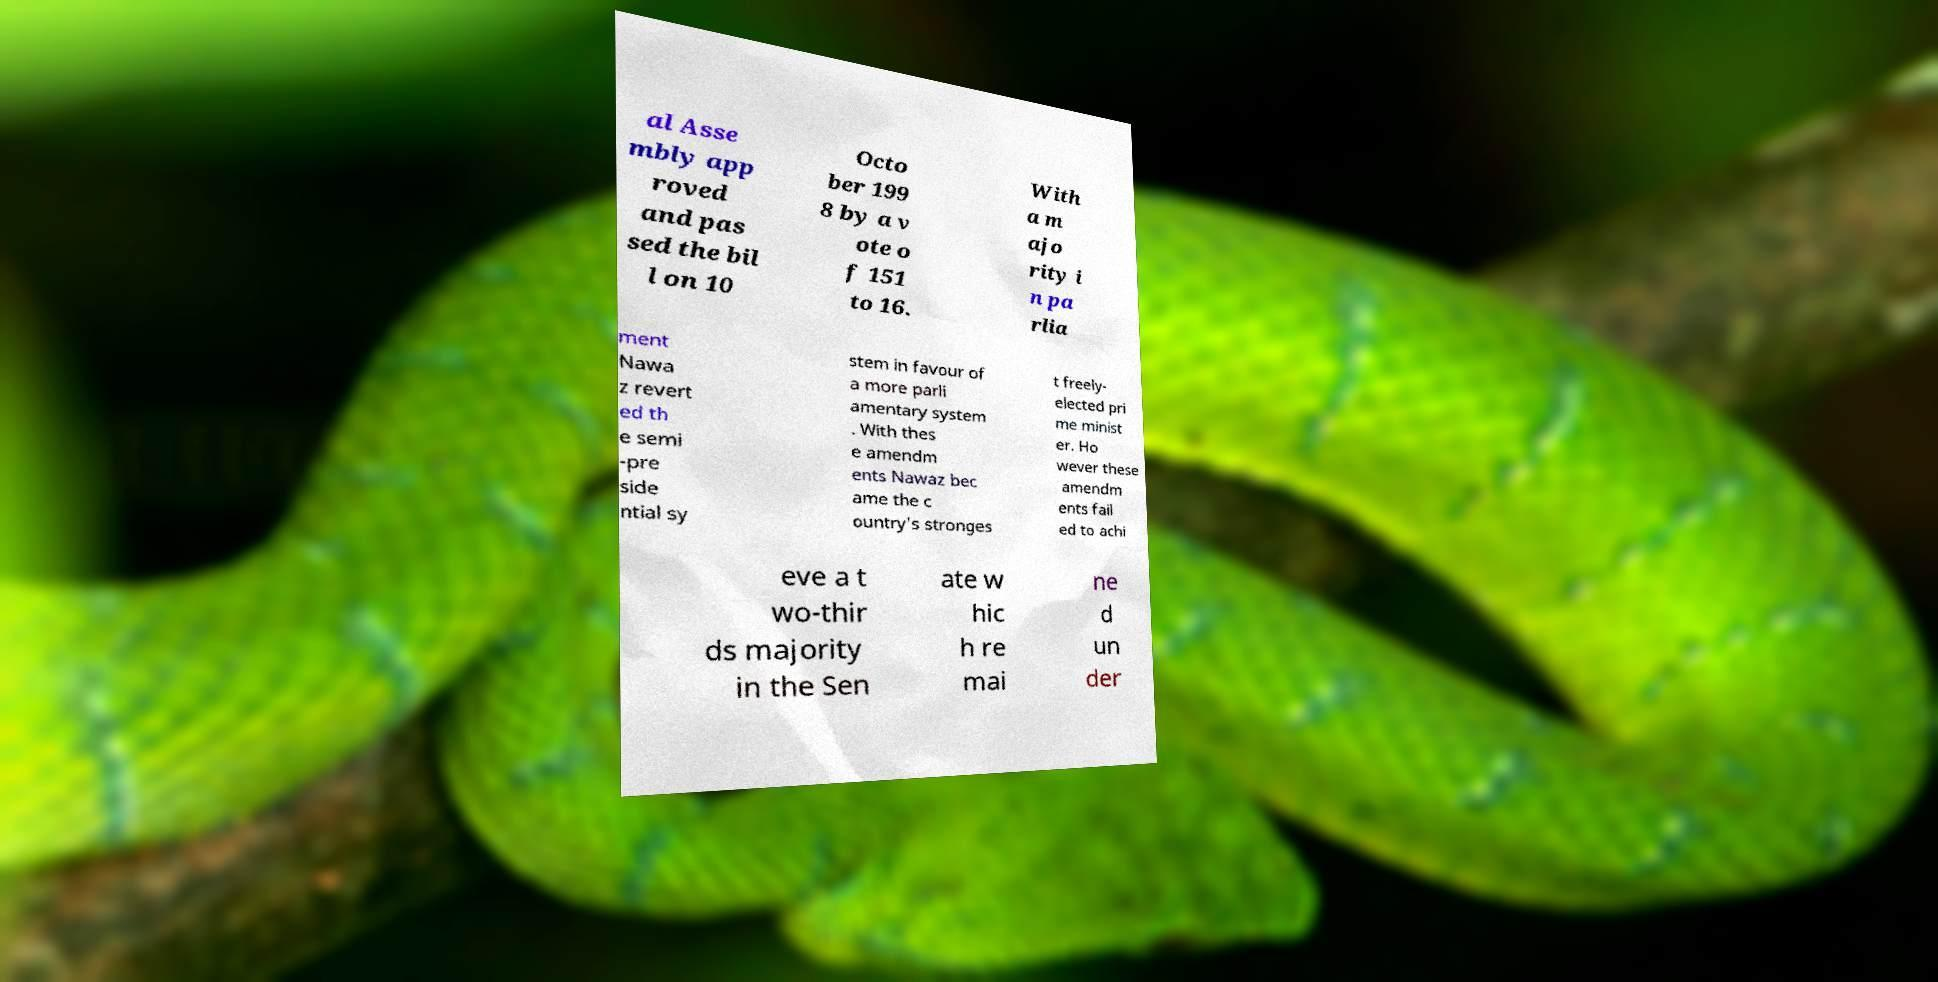Please identify and transcribe the text found in this image. al Asse mbly app roved and pas sed the bil l on 10 Octo ber 199 8 by a v ote o f 151 to 16. With a m ajo rity i n pa rlia ment Nawa z revert ed th e semi -pre side ntial sy stem in favour of a more parli amentary system . With thes e amendm ents Nawaz bec ame the c ountry's stronges t freely- elected pri me minist er. Ho wever these amendm ents fail ed to achi eve a t wo-thir ds majority in the Sen ate w hic h re mai ne d un der 